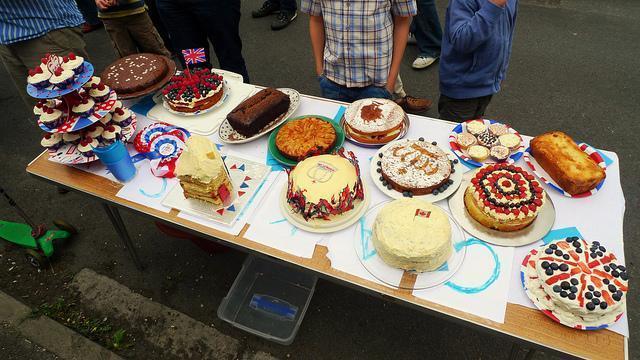How many people will be dining?
Give a very brief answer. 10. How many colors are the cupcakes?
Give a very brief answer. 3. How many people are there?
Give a very brief answer. 5. How many cakes are there?
Give a very brief answer. 8. 